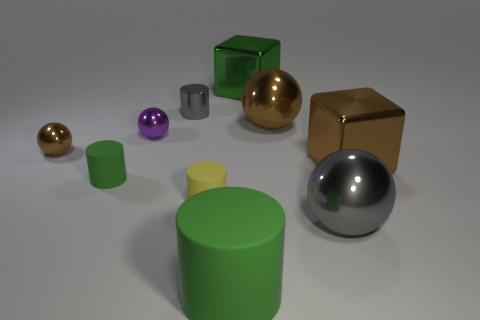How many things are tiny metal spheres that are in front of the purple metal thing or tiny cylinders?
Ensure brevity in your answer.  4. Are the big green cylinder and the small cylinder to the left of the gray cylinder made of the same material?
Your answer should be compact. Yes. There is a shiny thing in front of the yellow cylinder right of the small purple object; what is its shape?
Offer a terse response. Sphere. Does the metallic cylinder have the same color as the cylinder that is on the left side of the small purple sphere?
Provide a succinct answer. No. Are there any other things that have the same material as the small green cylinder?
Make the answer very short. Yes. What is the shape of the purple metal thing?
Your answer should be very brief. Sphere. There is a gray metallic thing behind the brown sphere left of the purple object; what is its size?
Give a very brief answer. Small. Are there an equal number of big matte things on the right side of the green metallic block and tiny purple objects that are in front of the large gray thing?
Offer a very short reply. Yes. What is the material of the tiny thing that is both to the left of the gray cylinder and in front of the tiny brown metallic sphere?
Ensure brevity in your answer.  Rubber. Do the gray shiny sphere and the green matte object left of the big green matte thing have the same size?
Provide a short and direct response. No. 